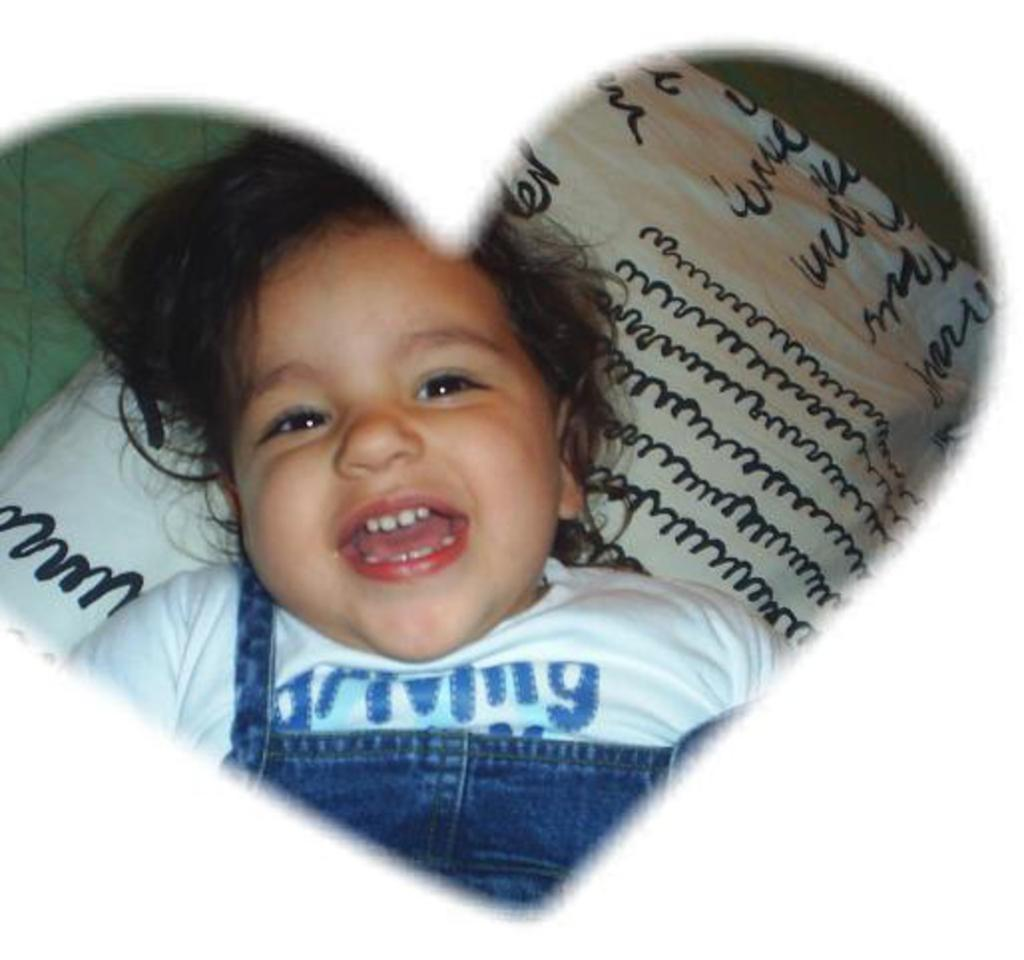What is the main subject of the image? The main subject of the image is a baby. What is the baby doing in the image? The baby is smiling in the image. What can be seen in the background of the image? There is a cushion in the background of the image. What type of pest can be seen crawling on the baby in the image? There is no pest present in the image, and therefore no such activity can be observed. 